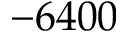<formula> <loc_0><loc_0><loc_500><loc_500>- 6 4 0 0</formula> 